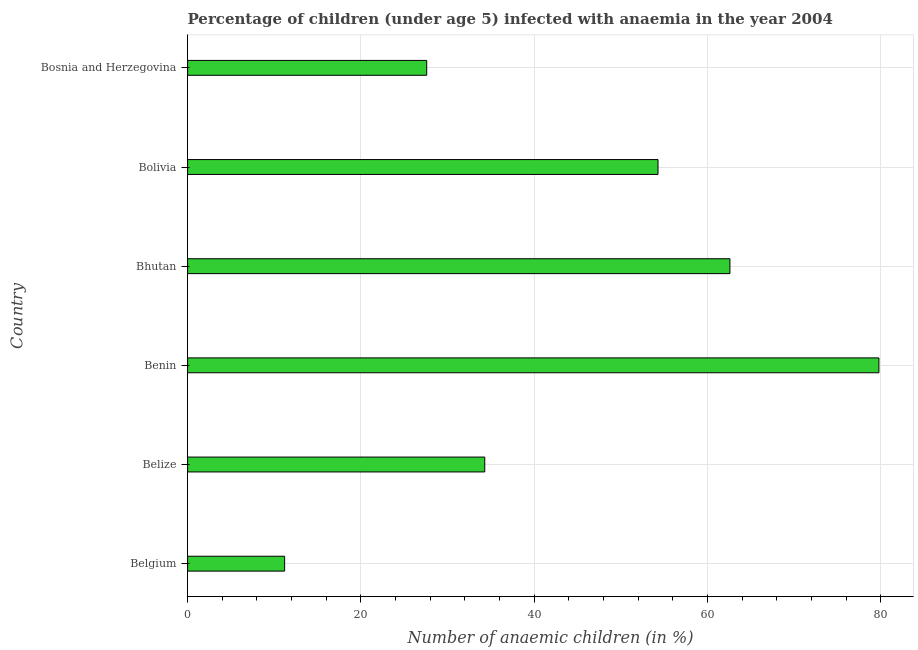Does the graph contain grids?
Provide a short and direct response. Yes. What is the title of the graph?
Provide a succinct answer. Percentage of children (under age 5) infected with anaemia in the year 2004. What is the label or title of the X-axis?
Keep it short and to the point. Number of anaemic children (in %). What is the label or title of the Y-axis?
Offer a very short reply. Country. What is the number of anaemic children in Belgium?
Offer a terse response. 11.2. Across all countries, what is the maximum number of anaemic children?
Your answer should be compact. 79.8. In which country was the number of anaemic children maximum?
Your answer should be compact. Benin. What is the sum of the number of anaemic children?
Your response must be concise. 269.8. What is the average number of anaemic children per country?
Provide a succinct answer. 44.97. What is the median number of anaemic children?
Offer a very short reply. 44.3. In how many countries, is the number of anaemic children greater than 72 %?
Keep it short and to the point. 1. What is the ratio of the number of anaemic children in Belize to that in Benin?
Your response must be concise. 0.43. Is the number of anaemic children in Belize less than that in Benin?
Make the answer very short. Yes. What is the difference between the highest and the lowest number of anaemic children?
Offer a very short reply. 68.6. In how many countries, is the number of anaemic children greater than the average number of anaemic children taken over all countries?
Make the answer very short. 3. How many bars are there?
Provide a succinct answer. 6. What is the difference between two consecutive major ticks on the X-axis?
Your answer should be very brief. 20. Are the values on the major ticks of X-axis written in scientific E-notation?
Your response must be concise. No. What is the Number of anaemic children (in %) of Belgium?
Your answer should be very brief. 11.2. What is the Number of anaemic children (in %) in Belize?
Offer a very short reply. 34.3. What is the Number of anaemic children (in %) in Benin?
Offer a terse response. 79.8. What is the Number of anaemic children (in %) in Bhutan?
Offer a terse response. 62.6. What is the Number of anaemic children (in %) in Bolivia?
Your answer should be compact. 54.3. What is the Number of anaemic children (in %) in Bosnia and Herzegovina?
Your response must be concise. 27.6. What is the difference between the Number of anaemic children (in %) in Belgium and Belize?
Ensure brevity in your answer.  -23.1. What is the difference between the Number of anaemic children (in %) in Belgium and Benin?
Make the answer very short. -68.6. What is the difference between the Number of anaemic children (in %) in Belgium and Bhutan?
Your answer should be compact. -51.4. What is the difference between the Number of anaemic children (in %) in Belgium and Bolivia?
Provide a succinct answer. -43.1. What is the difference between the Number of anaemic children (in %) in Belgium and Bosnia and Herzegovina?
Your answer should be very brief. -16.4. What is the difference between the Number of anaemic children (in %) in Belize and Benin?
Give a very brief answer. -45.5. What is the difference between the Number of anaemic children (in %) in Belize and Bhutan?
Your answer should be compact. -28.3. What is the difference between the Number of anaemic children (in %) in Belize and Bolivia?
Provide a succinct answer. -20. What is the difference between the Number of anaemic children (in %) in Belize and Bosnia and Herzegovina?
Give a very brief answer. 6.7. What is the difference between the Number of anaemic children (in %) in Benin and Bosnia and Herzegovina?
Make the answer very short. 52.2. What is the difference between the Number of anaemic children (in %) in Bolivia and Bosnia and Herzegovina?
Offer a very short reply. 26.7. What is the ratio of the Number of anaemic children (in %) in Belgium to that in Belize?
Ensure brevity in your answer.  0.33. What is the ratio of the Number of anaemic children (in %) in Belgium to that in Benin?
Give a very brief answer. 0.14. What is the ratio of the Number of anaemic children (in %) in Belgium to that in Bhutan?
Keep it short and to the point. 0.18. What is the ratio of the Number of anaemic children (in %) in Belgium to that in Bolivia?
Make the answer very short. 0.21. What is the ratio of the Number of anaemic children (in %) in Belgium to that in Bosnia and Herzegovina?
Your answer should be very brief. 0.41. What is the ratio of the Number of anaemic children (in %) in Belize to that in Benin?
Give a very brief answer. 0.43. What is the ratio of the Number of anaemic children (in %) in Belize to that in Bhutan?
Keep it short and to the point. 0.55. What is the ratio of the Number of anaemic children (in %) in Belize to that in Bolivia?
Your response must be concise. 0.63. What is the ratio of the Number of anaemic children (in %) in Belize to that in Bosnia and Herzegovina?
Your answer should be compact. 1.24. What is the ratio of the Number of anaemic children (in %) in Benin to that in Bhutan?
Offer a very short reply. 1.27. What is the ratio of the Number of anaemic children (in %) in Benin to that in Bolivia?
Keep it short and to the point. 1.47. What is the ratio of the Number of anaemic children (in %) in Benin to that in Bosnia and Herzegovina?
Provide a succinct answer. 2.89. What is the ratio of the Number of anaemic children (in %) in Bhutan to that in Bolivia?
Ensure brevity in your answer.  1.15. What is the ratio of the Number of anaemic children (in %) in Bhutan to that in Bosnia and Herzegovina?
Give a very brief answer. 2.27. What is the ratio of the Number of anaemic children (in %) in Bolivia to that in Bosnia and Herzegovina?
Ensure brevity in your answer.  1.97. 